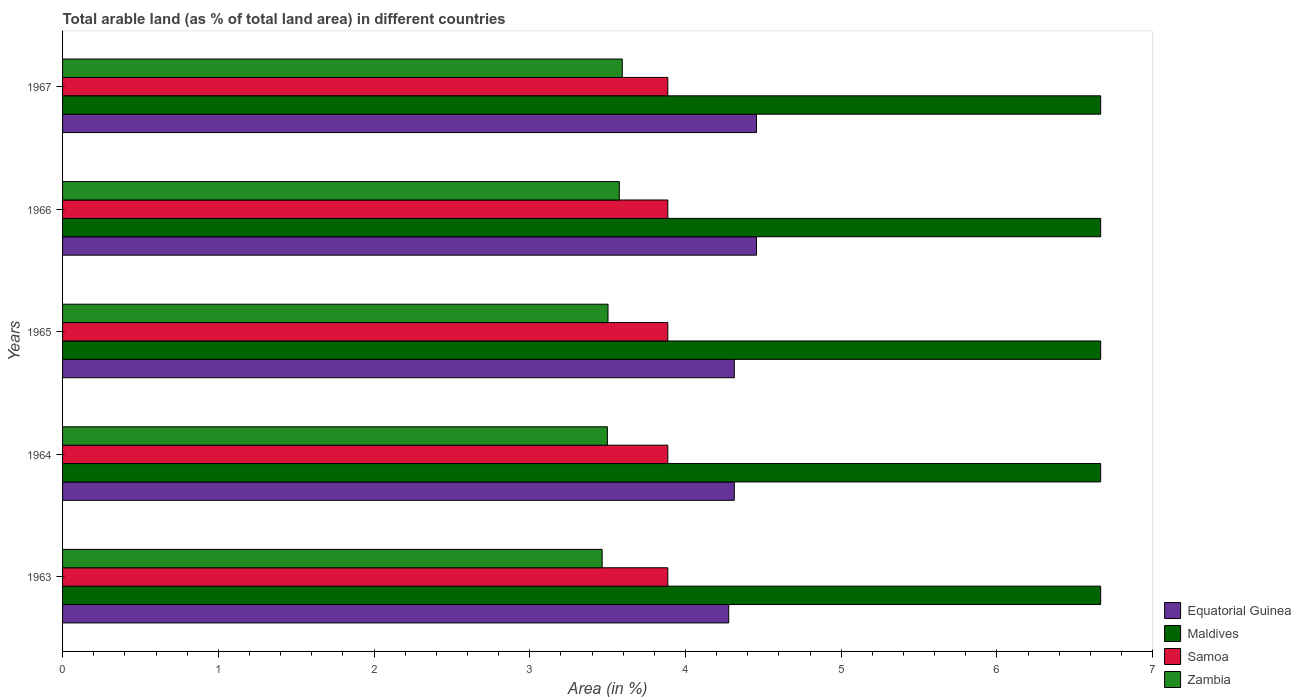How many groups of bars are there?
Your response must be concise. 5. What is the label of the 4th group of bars from the top?
Your answer should be very brief. 1964. In how many cases, is the number of bars for a given year not equal to the number of legend labels?
Make the answer very short. 0. What is the percentage of arable land in Samoa in 1963?
Make the answer very short. 3.89. Across all years, what is the maximum percentage of arable land in Equatorial Guinea?
Provide a short and direct response. 4.46. Across all years, what is the minimum percentage of arable land in Samoa?
Provide a succinct answer. 3.89. In which year was the percentage of arable land in Equatorial Guinea maximum?
Make the answer very short. 1966. In which year was the percentage of arable land in Maldives minimum?
Provide a succinct answer. 1963. What is the total percentage of arable land in Equatorial Guinea in the graph?
Your answer should be compact. 21.82. What is the difference between the percentage of arable land in Equatorial Guinea in 1963 and that in 1964?
Your answer should be very brief. -0.04. What is the difference between the percentage of arable land in Equatorial Guinea in 1965 and the percentage of arable land in Samoa in 1963?
Provide a short and direct response. 0.43. What is the average percentage of arable land in Samoa per year?
Provide a succinct answer. 3.89. In the year 1966, what is the difference between the percentage of arable land in Samoa and percentage of arable land in Zambia?
Give a very brief answer. 0.31. What is the ratio of the percentage of arable land in Equatorial Guinea in 1965 to that in 1967?
Your response must be concise. 0.97. Is the percentage of arable land in Equatorial Guinea in 1963 less than that in 1965?
Ensure brevity in your answer.  Yes. What is the difference between the highest and the second highest percentage of arable land in Zambia?
Ensure brevity in your answer.  0.02. What is the difference between the highest and the lowest percentage of arable land in Equatorial Guinea?
Offer a very short reply. 0.18. In how many years, is the percentage of arable land in Equatorial Guinea greater than the average percentage of arable land in Equatorial Guinea taken over all years?
Offer a terse response. 2. Is the sum of the percentage of arable land in Zambia in 1966 and 1967 greater than the maximum percentage of arable land in Equatorial Guinea across all years?
Offer a very short reply. Yes. What does the 1st bar from the top in 1965 represents?
Keep it short and to the point. Zambia. What does the 2nd bar from the bottom in 1963 represents?
Offer a terse response. Maldives. Is it the case that in every year, the sum of the percentage of arable land in Zambia and percentage of arable land in Samoa is greater than the percentage of arable land in Equatorial Guinea?
Ensure brevity in your answer.  Yes. Are all the bars in the graph horizontal?
Offer a very short reply. Yes. How many years are there in the graph?
Ensure brevity in your answer.  5. How many legend labels are there?
Provide a short and direct response. 4. What is the title of the graph?
Ensure brevity in your answer.  Total arable land (as % of total land area) in different countries. What is the label or title of the X-axis?
Your answer should be very brief. Area (in %). What is the Area (in %) in Equatorial Guinea in 1963?
Offer a terse response. 4.28. What is the Area (in %) of Maldives in 1963?
Offer a terse response. 6.67. What is the Area (in %) in Samoa in 1963?
Ensure brevity in your answer.  3.89. What is the Area (in %) of Zambia in 1963?
Offer a very short reply. 3.47. What is the Area (in %) in Equatorial Guinea in 1964?
Your answer should be compact. 4.31. What is the Area (in %) in Maldives in 1964?
Your answer should be compact. 6.67. What is the Area (in %) of Samoa in 1964?
Provide a short and direct response. 3.89. What is the Area (in %) in Zambia in 1964?
Offer a very short reply. 3.5. What is the Area (in %) in Equatorial Guinea in 1965?
Keep it short and to the point. 4.31. What is the Area (in %) in Maldives in 1965?
Provide a succinct answer. 6.67. What is the Area (in %) in Samoa in 1965?
Provide a short and direct response. 3.89. What is the Area (in %) in Zambia in 1965?
Provide a short and direct response. 3.5. What is the Area (in %) in Equatorial Guinea in 1966?
Ensure brevity in your answer.  4.46. What is the Area (in %) of Maldives in 1966?
Provide a short and direct response. 6.67. What is the Area (in %) in Samoa in 1966?
Your answer should be very brief. 3.89. What is the Area (in %) of Zambia in 1966?
Keep it short and to the point. 3.58. What is the Area (in %) of Equatorial Guinea in 1967?
Offer a very short reply. 4.46. What is the Area (in %) of Maldives in 1967?
Ensure brevity in your answer.  6.67. What is the Area (in %) of Samoa in 1967?
Make the answer very short. 3.89. What is the Area (in %) of Zambia in 1967?
Your response must be concise. 3.59. Across all years, what is the maximum Area (in %) of Equatorial Guinea?
Provide a short and direct response. 4.46. Across all years, what is the maximum Area (in %) of Maldives?
Offer a terse response. 6.67. Across all years, what is the maximum Area (in %) of Samoa?
Your response must be concise. 3.89. Across all years, what is the maximum Area (in %) in Zambia?
Give a very brief answer. 3.59. Across all years, what is the minimum Area (in %) in Equatorial Guinea?
Offer a terse response. 4.28. Across all years, what is the minimum Area (in %) of Maldives?
Your response must be concise. 6.67. Across all years, what is the minimum Area (in %) in Samoa?
Your response must be concise. 3.89. Across all years, what is the minimum Area (in %) in Zambia?
Your answer should be compact. 3.47. What is the total Area (in %) in Equatorial Guinea in the graph?
Your answer should be very brief. 21.82. What is the total Area (in %) in Maldives in the graph?
Your answer should be very brief. 33.33. What is the total Area (in %) of Samoa in the graph?
Ensure brevity in your answer.  19.43. What is the total Area (in %) of Zambia in the graph?
Keep it short and to the point. 17.64. What is the difference between the Area (in %) in Equatorial Guinea in 1963 and that in 1964?
Your response must be concise. -0.04. What is the difference between the Area (in %) of Zambia in 1963 and that in 1964?
Offer a very short reply. -0.03. What is the difference between the Area (in %) of Equatorial Guinea in 1963 and that in 1965?
Provide a short and direct response. -0.04. What is the difference between the Area (in %) in Zambia in 1963 and that in 1965?
Provide a short and direct response. -0.04. What is the difference between the Area (in %) of Equatorial Guinea in 1963 and that in 1966?
Your response must be concise. -0.18. What is the difference between the Area (in %) of Samoa in 1963 and that in 1966?
Make the answer very short. 0. What is the difference between the Area (in %) of Zambia in 1963 and that in 1966?
Provide a succinct answer. -0.11. What is the difference between the Area (in %) in Equatorial Guinea in 1963 and that in 1967?
Offer a very short reply. -0.18. What is the difference between the Area (in %) of Maldives in 1963 and that in 1967?
Your answer should be compact. 0. What is the difference between the Area (in %) in Samoa in 1963 and that in 1967?
Offer a terse response. 0. What is the difference between the Area (in %) in Zambia in 1963 and that in 1967?
Offer a very short reply. -0.13. What is the difference between the Area (in %) of Maldives in 1964 and that in 1965?
Your response must be concise. 0. What is the difference between the Area (in %) in Zambia in 1964 and that in 1965?
Your answer should be compact. -0. What is the difference between the Area (in %) of Equatorial Guinea in 1964 and that in 1966?
Provide a succinct answer. -0.14. What is the difference between the Area (in %) of Maldives in 1964 and that in 1966?
Your answer should be compact. 0. What is the difference between the Area (in %) in Zambia in 1964 and that in 1966?
Your answer should be very brief. -0.08. What is the difference between the Area (in %) in Equatorial Guinea in 1964 and that in 1967?
Give a very brief answer. -0.14. What is the difference between the Area (in %) of Samoa in 1964 and that in 1967?
Provide a succinct answer. 0. What is the difference between the Area (in %) in Zambia in 1964 and that in 1967?
Your answer should be very brief. -0.1. What is the difference between the Area (in %) in Equatorial Guinea in 1965 and that in 1966?
Ensure brevity in your answer.  -0.14. What is the difference between the Area (in %) in Maldives in 1965 and that in 1966?
Provide a short and direct response. 0. What is the difference between the Area (in %) in Samoa in 1965 and that in 1966?
Your answer should be compact. 0. What is the difference between the Area (in %) in Zambia in 1965 and that in 1966?
Provide a short and direct response. -0.07. What is the difference between the Area (in %) of Equatorial Guinea in 1965 and that in 1967?
Provide a short and direct response. -0.14. What is the difference between the Area (in %) of Maldives in 1965 and that in 1967?
Your answer should be compact. 0. What is the difference between the Area (in %) of Zambia in 1965 and that in 1967?
Provide a succinct answer. -0.09. What is the difference between the Area (in %) of Equatorial Guinea in 1966 and that in 1967?
Your response must be concise. 0. What is the difference between the Area (in %) of Maldives in 1966 and that in 1967?
Provide a succinct answer. 0. What is the difference between the Area (in %) in Zambia in 1966 and that in 1967?
Ensure brevity in your answer.  -0.02. What is the difference between the Area (in %) in Equatorial Guinea in 1963 and the Area (in %) in Maldives in 1964?
Offer a very short reply. -2.39. What is the difference between the Area (in %) in Equatorial Guinea in 1963 and the Area (in %) in Samoa in 1964?
Provide a succinct answer. 0.39. What is the difference between the Area (in %) of Equatorial Guinea in 1963 and the Area (in %) of Zambia in 1964?
Give a very brief answer. 0.78. What is the difference between the Area (in %) in Maldives in 1963 and the Area (in %) in Samoa in 1964?
Offer a terse response. 2.78. What is the difference between the Area (in %) of Maldives in 1963 and the Area (in %) of Zambia in 1964?
Make the answer very short. 3.17. What is the difference between the Area (in %) of Samoa in 1963 and the Area (in %) of Zambia in 1964?
Your answer should be very brief. 0.39. What is the difference between the Area (in %) of Equatorial Guinea in 1963 and the Area (in %) of Maldives in 1965?
Give a very brief answer. -2.39. What is the difference between the Area (in %) in Equatorial Guinea in 1963 and the Area (in %) in Samoa in 1965?
Your answer should be compact. 0.39. What is the difference between the Area (in %) of Equatorial Guinea in 1963 and the Area (in %) of Zambia in 1965?
Make the answer very short. 0.78. What is the difference between the Area (in %) of Maldives in 1963 and the Area (in %) of Samoa in 1965?
Your response must be concise. 2.78. What is the difference between the Area (in %) of Maldives in 1963 and the Area (in %) of Zambia in 1965?
Provide a succinct answer. 3.16. What is the difference between the Area (in %) of Samoa in 1963 and the Area (in %) of Zambia in 1965?
Make the answer very short. 0.38. What is the difference between the Area (in %) in Equatorial Guinea in 1963 and the Area (in %) in Maldives in 1966?
Provide a succinct answer. -2.39. What is the difference between the Area (in %) in Equatorial Guinea in 1963 and the Area (in %) in Samoa in 1966?
Your answer should be very brief. 0.39. What is the difference between the Area (in %) in Equatorial Guinea in 1963 and the Area (in %) in Zambia in 1966?
Make the answer very short. 0.7. What is the difference between the Area (in %) in Maldives in 1963 and the Area (in %) in Samoa in 1966?
Your answer should be very brief. 2.78. What is the difference between the Area (in %) of Maldives in 1963 and the Area (in %) of Zambia in 1966?
Provide a succinct answer. 3.09. What is the difference between the Area (in %) in Samoa in 1963 and the Area (in %) in Zambia in 1966?
Give a very brief answer. 0.31. What is the difference between the Area (in %) in Equatorial Guinea in 1963 and the Area (in %) in Maldives in 1967?
Offer a very short reply. -2.39. What is the difference between the Area (in %) in Equatorial Guinea in 1963 and the Area (in %) in Samoa in 1967?
Keep it short and to the point. 0.39. What is the difference between the Area (in %) of Equatorial Guinea in 1963 and the Area (in %) of Zambia in 1967?
Give a very brief answer. 0.68. What is the difference between the Area (in %) in Maldives in 1963 and the Area (in %) in Samoa in 1967?
Your answer should be compact. 2.78. What is the difference between the Area (in %) in Maldives in 1963 and the Area (in %) in Zambia in 1967?
Offer a very short reply. 3.07. What is the difference between the Area (in %) of Samoa in 1963 and the Area (in %) of Zambia in 1967?
Provide a succinct answer. 0.29. What is the difference between the Area (in %) of Equatorial Guinea in 1964 and the Area (in %) of Maldives in 1965?
Keep it short and to the point. -2.35. What is the difference between the Area (in %) of Equatorial Guinea in 1964 and the Area (in %) of Samoa in 1965?
Make the answer very short. 0.43. What is the difference between the Area (in %) in Equatorial Guinea in 1964 and the Area (in %) in Zambia in 1965?
Your answer should be very brief. 0.81. What is the difference between the Area (in %) in Maldives in 1964 and the Area (in %) in Samoa in 1965?
Give a very brief answer. 2.78. What is the difference between the Area (in %) of Maldives in 1964 and the Area (in %) of Zambia in 1965?
Give a very brief answer. 3.16. What is the difference between the Area (in %) of Samoa in 1964 and the Area (in %) of Zambia in 1965?
Your answer should be very brief. 0.38. What is the difference between the Area (in %) in Equatorial Guinea in 1964 and the Area (in %) in Maldives in 1966?
Make the answer very short. -2.35. What is the difference between the Area (in %) in Equatorial Guinea in 1964 and the Area (in %) in Samoa in 1966?
Give a very brief answer. 0.43. What is the difference between the Area (in %) of Equatorial Guinea in 1964 and the Area (in %) of Zambia in 1966?
Give a very brief answer. 0.74. What is the difference between the Area (in %) in Maldives in 1964 and the Area (in %) in Samoa in 1966?
Your response must be concise. 2.78. What is the difference between the Area (in %) in Maldives in 1964 and the Area (in %) in Zambia in 1966?
Your answer should be compact. 3.09. What is the difference between the Area (in %) of Samoa in 1964 and the Area (in %) of Zambia in 1966?
Make the answer very short. 0.31. What is the difference between the Area (in %) of Equatorial Guinea in 1964 and the Area (in %) of Maldives in 1967?
Keep it short and to the point. -2.35. What is the difference between the Area (in %) in Equatorial Guinea in 1964 and the Area (in %) in Samoa in 1967?
Give a very brief answer. 0.43. What is the difference between the Area (in %) of Equatorial Guinea in 1964 and the Area (in %) of Zambia in 1967?
Your answer should be very brief. 0.72. What is the difference between the Area (in %) in Maldives in 1964 and the Area (in %) in Samoa in 1967?
Your response must be concise. 2.78. What is the difference between the Area (in %) of Maldives in 1964 and the Area (in %) of Zambia in 1967?
Give a very brief answer. 3.07. What is the difference between the Area (in %) in Samoa in 1964 and the Area (in %) in Zambia in 1967?
Your answer should be compact. 0.29. What is the difference between the Area (in %) in Equatorial Guinea in 1965 and the Area (in %) in Maldives in 1966?
Make the answer very short. -2.35. What is the difference between the Area (in %) in Equatorial Guinea in 1965 and the Area (in %) in Samoa in 1966?
Give a very brief answer. 0.43. What is the difference between the Area (in %) in Equatorial Guinea in 1965 and the Area (in %) in Zambia in 1966?
Offer a terse response. 0.74. What is the difference between the Area (in %) of Maldives in 1965 and the Area (in %) of Samoa in 1966?
Your response must be concise. 2.78. What is the difference between the Area (in %) of Maldives in 1965 and the Area (in %) of Zambia in 1966?
Make the answer very short. 3.09. What is the difference between the Area (in %) in Samoa in 1965 and the Area (in %) in Zambia in 1966?
Ensure brevity in your answer.  0.31. What is the difference between the Area (in %) of Equatorial Guinea in 1965 and the Area (in %) of Maldives in 1967?
Make the answer very short. -2.35. What is the difference between the Area (in %) in Equatorial Guinea in 1965 and the Area (in %) in Samoa in 1967?
Make the answer very short. 0.43. What is the difference between the Area (in %) in Equatorial Guinea in 1965 and the Area (in %) in Zambia in 1967?
Offer a terse response. 0.72. What is the difference between the Area (in %) in Maldives in 1965 and the Area (in %) in Samoa in 1967?
Your response must be concise. 2.78. What is the difference between the Area (in %) in Maldives in 1965 and the Area (in %) in Zambia in 1967?
Make the answer very short. 3.07. What is the difference between the Area (in %) of Samoa in 1965 and the Area (in %) of Zambia in 1967?
Your answer should be very brief. 0.29. What is the difference between the Area (in %) of Equatorial Guinea in 1966 and the Area (in %) of Maldives in 1967?
Offer a very short reply. -2.21. What is the difference between the Area (in %) in Equatorial Guinea in 1966 and the Area (in %) in Samoa in 1967?
Offer a very short reply. 0.57. What is the difference between the Area (in %) of Equatorial Guinea in 1966 and the Area (in %) of Zambia in 1967?
Your response must be concise. 0.86. What is the difference between the Area (in %) in Maldives in 1966 and the Area (in %) in Samoa in 1967?
Keep it short and to the point. 2.78. What is the difference between the Area (in %) in Maldives in 1966 and the Area (in %) in Zambia in 1967?
Your answer should be very brief. 3.07. What is the difference between the Area (in %) in Samoa in 1966 and the Area (in %) in Zambia in 1967?
Your answer should be compact. 0.29. What is the average Area (in %) of Equatorial Guinea per year?
Make the answer very short. 4.36. What is the average Area (in %) of Maldives per year?
Give a very brief answer. 6.67. What is the average Area (in %) of Samoa per year?
Offer a terse response. 3.89. What is the average Area (in %) in Zambia per year?
Give a very brief answer. 3.53. In the year 1963, what is the difference between the Area (in %) in Equatorial Guinea and Area (in %) in Maldives?
Offer a terse response. -2.39. In the year 1963, what is the difference between the Area (in %) in Equatorial Guinea and Area (in %) in Samoa?
Offer a terse response. 0.39. In the year 1963, what is the difference between the Area (in %) of Equatorial Guinea and Area (in %) of Zambia?
Ensure brevity in your answer.  0.81. In the year 1963, what is the difference between the Area (in %) in Maldives and Area (in %) in Samoa?
Provide a short and direct response. 2.78. In the year 1963, what is the difference between the Area (in %) of Maldives and Area (in %) of Zambia?
Ensure brevity in your answer.  3.2. In the year 1963, what is the difference between the Area (in %) of Samoa and Area (in %) of Zambia?
Your answer should be very brief. 0.42. In the year 1964, what is the difference between the Area (in %) in Equatorial Guinea and Area (in %) in Maldives?
Make the answer very short. -2.35. In the year 1964, what is the difference between the Area (in %) of Equatorial Guinea and Area (in %) of Samoa?
Give a very brief answer. 0.43. In the year 1964, what is the difference between the Area (in %) in Equatorial Guinea and Area (in %) in Zambia?
Your answer should be very brief. 0.81. In the year 1964, what is the difference between the Area (in %) in Maldives and Area (in %) in Samoa?
Keep it short and to the point. 2.78. In the year 1964, what is the difference between the Area (in %) of Maldives and Area (in %) of Zambia?
Your answer should be compact. 3.17. In the year 1964, what is the difference between the Area (in %) of Samoa and Area (in %) of Zambia?
Your response must be concise. 0.39. In the year 1965, what is the difference between the Area (in %) of Equatorial Guinea and Area (in %) of Maldives?
Make the answer very short. -2.35. In the year 1965, what is the difference between the Area (in %) of Equatorial Guinea and Area (in %) of Samoa?
Provide a succinct answer. 0.43. In the year 1965, what is the difference between the Area (in %) in Equatorial Guinea and Area (in %) in Zambia?
Give a very brief answer. 0.81. In the year 1965, what is the difference between the Area (in %) in Maldives and Area (in %) in Samoa?
Ensure brevity in your answer.  2.78. In the year 1965, what is the difference between the Area (in %) in Maldives and Area (in %) in Zambia?
Your answer should be very brief. 3.16. In the year 1965, what is the difference between the Area (in %) of Samoa and Area (in %) of Zambia?
Your answer should be very brief. 0.38. In the year 1966, what is the difference between the Area (in %) of Equatorial Guinea and Area (in %) of Maldives?
Ensure brevity in your answer.  -2.21. In the year 1966, what is the difference between the Area (in %) of Equatorial Guinea and Area (in %) of Samoa?
Give a very brief answer. 0.57. In the year 1966, what is the difference between the Area (in %) in Equatorial Guinea and Area (in %) in Zambia?
Provide a short and direct response. 0.88. In the year 1966, what is the difference between the Area (in %) of Maldives and Area (in %) of Samoa?
Your answer should be very brief. 2.78. In the year 1966, what is the difference between the Area (in %) in Maldives and Area (in %) in Zambia?
Keep it short and to the point. 3.09. In the year 1966, what is the difference between the Area (in %) in Samoa and Area (in %) in Zambia?
Offer a terse response. 0.31. In the year 1967, what is the difference between the Area (in %) in Equatorial Guinea and Area (in %) in Maldives?
Keep it short and to the point. -2.21. In the year 1967, what is the difference between the Area (in %) of Equatorial Guinea and Area (in %) of Samoa?
Make the answer very short. 0.57. In the year 1967, what is the difference between the Area (in %) of Equatorial Guinea and Area (in %) of Zambia?
Your response must be concise. 0.86. In the year 1967, what is the difference between the Area (in %) of Maldives and Area (in %) of Samoa?
Keep it short and to the point. 2.78. In the year 1967, what is the difference between the Area (in %) in Maldives and Area (in %) in Zambia?
Keep it short and to the point. 3.07. In the year 1967, what is the difference between the Area (in %) in Samoa and Area (in %) in Zambia?
Your answer should be compact. 0.29. What is the ratio of the Area (in %) of Equatorial Guinea in 1963 to that in 1964?
Provide a succinct answer. 0.99. What is the ratio of the Area (in %) of Equatorial Guinea in 1963 to that in 1965?
Offer a terse response. 0.99. What is the ratio of the Area (in %) of Maldives in 1963 to that in 1965?
Offer a very short reply. 1. What is the ratio of the Area (in %) of Zambia in 1963 to that in 1965?
Offer a very short reply. 0.99. What is the ratio of the Area (in %) in Equatorial Guinea in 1963 to that in 1966?
Your answer should be very brief. 0.96. What is the ratio of the Area (in %) of Maldives in 1963 to that in 1966?
Your response must be concise. 1. What is the ratio of the Area (in %) of Zambia in 1963 to that in 1966?
Your response must be concise. 0.97. What is the ratio of the Area (in %) in Zambia in 1963 to that in 1967?
Ensure brevity in your answer.  0.96. What is the ratio of the Area (in %) in Equatorial Guinea in 1964 to that in 1965?
Your response must be concise. 1. What is the ratio of the Area (in %) in Maldives in 1964 to that in 1965?
Offer a very short reply. 1. What is the ratio of the Area (in %) of Samoa in 1964 to that in 1965?
Your answer should be very brief. 1. What is the ratio of the Area (in %) in Equatorial Guinea in 1964 to that in 1966?
Your answer should be compact. 0.97. What is the ratio of the Area (in %) in Samoa in 1964 to that in 1966?
Offer a terse response. 1. What is the ratio of the Area (in %) in Zambia in 1964 to that in 1966?
Offer a very short reply. 0.98. What is the ratio of the Area (in %) in Zambia in 1964 to that in 1967?
Your answer should be compact. 0.97. What is the ratio of the Area (in %) in Equatorial Guinea in 1965 to that in 1966?
Provide a short and direct response. 0.97. What is the ratio of the Area (in %) of Zambia in 1965 to that in 1966?
Offer a terse response. 0.98. What is the ratio of the Area (in %) in Samoa in 1965 to that in 1967?
Ensure brevity in your answer.  1. What is the ratio of the Area (in %) in Zambia in 1965 to that in 1967?
Provide a succinct answer. 0.97. What is the ratio of the Area (in %) of Samoa in 1966 to that in 1967?
Give a very brief answer. 1. What is the ratio of the Area (in %) of Zambia in 1966 to that in 1967?
Your answer should be very brief. 0.99. What is the difference between the highest and the second highest Area (in %) of Zambia?
Your answer should be very brief. 0.02. What is the difference between the highest and the lowest Area (in %) in Equatorial Guinea?
Keep it short and to the point. 0.18. What is the difference between the highest and the lowest Area (in %) of Zambia?
Offer a terse response. 0.13. 